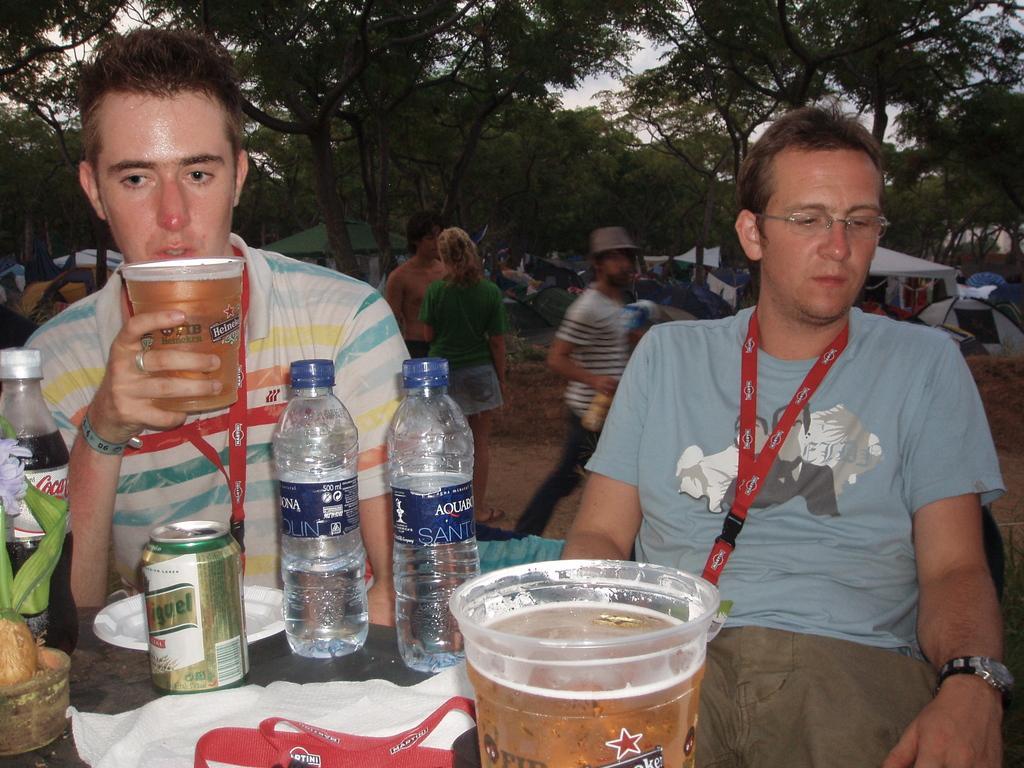Can you describe this image briefly? As we can see in the image there are trees, umbrellas, few people here and there. In the front there are two people sitting. On the left side there is a table. On table there is a glass, bottles, a cloth, plate and tin. 